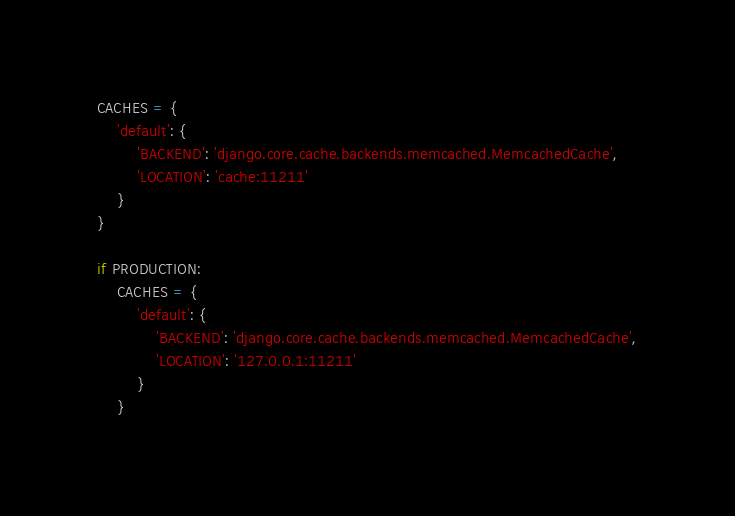<code> <loc_0><loc_0><loc_500><loc_500><_Python_>CACHES = {
    'default': {
        'BACKEND': 'django.core.cache.backends.memcached.MemcachedCache',
        'LOCATION': 'cache:11211'
    }
}

if PRODUCTION:
    CACHES = {
        'default': {
            'BACKEND': 'django.core.cache.backends.memcached.MemcachedCache',
            'LOCATION': '127.0.0.1:11211'
        }
    }
</code> 